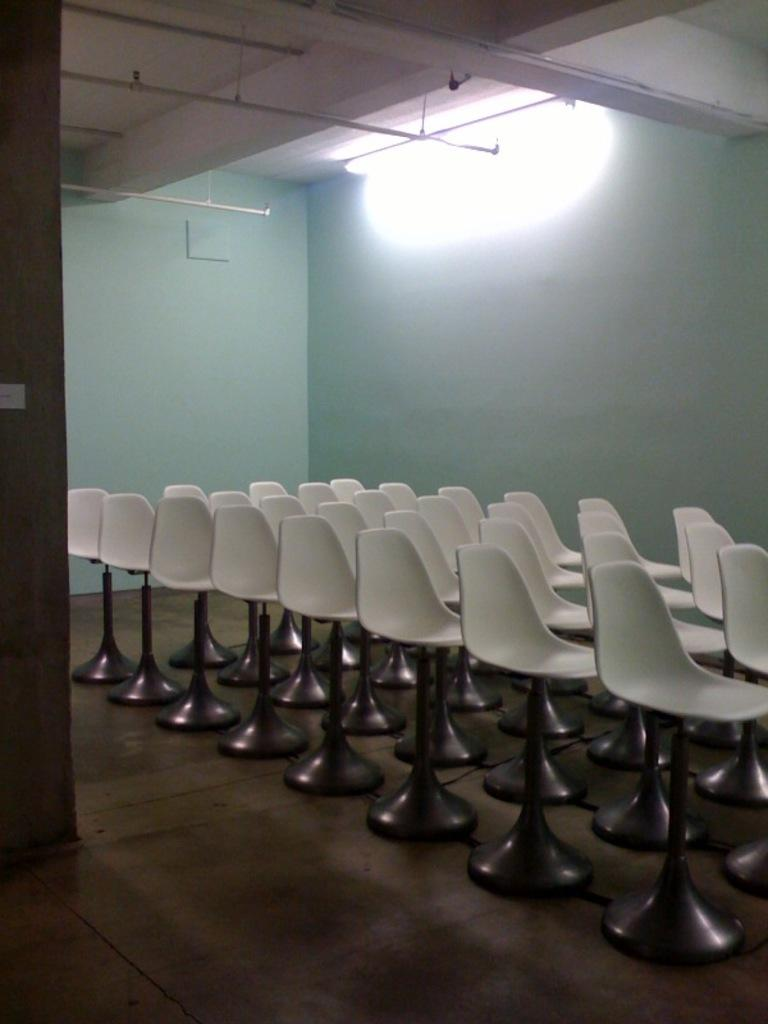What objects are present in the image that are typically used for sitting? There are empty chairs in the image. What can be seen in the background of the image? There is a wall in the background of the image. What type of lighting is present in the image? There is a light on the ceiling in the image. What committee is meeting in the image? There is no committee meeting in the image, as it only shows empty chairs and a wall in the background. 